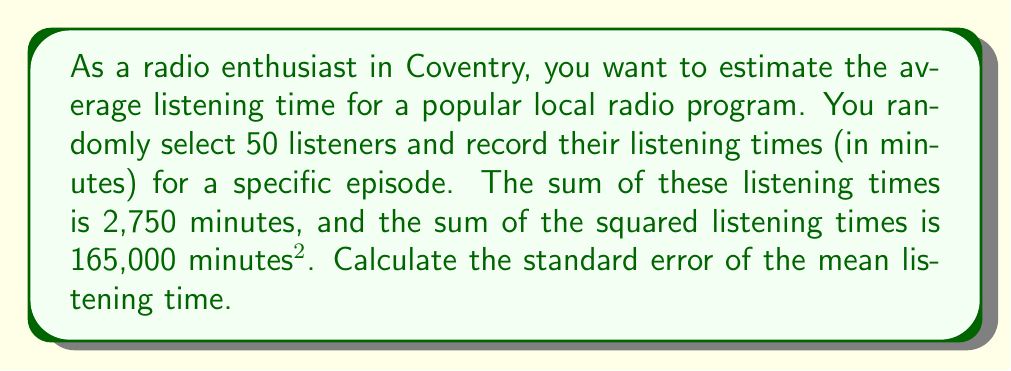Provide a solution to this math problem. To calculate the standard error of the mean, we'll follow these steps:

1) First, we need to calculate the sample mean ($\bar{x}$):
   $$\bar{x} = \frac{\sum x}{n} = \frac{2750}{50} = 55$$ minutes

2) Next, we need to calculate the sample variance ($s^2$):
   $$s^2 = \frac{\sum x^2 - n\bar{x}^2}{n-1}$$

   Where $\sum x^2 = 165000$ and $n\bar{x}^2 = 50 \times 55^2 = 151250$

   $$s^2 = \frac{165000 - 151250}{49} = \frac{13750}{49} = 280.61$$

3) Now we can calculate the sample standard deviation ($s$):
   $$s = \sqrt{280.61} = 16.75$$ minutes

4) Finally, we can calculate the standard error of the mean ($SE_{\bar{x}}$):
   $$SE_{\bar{x}} = \frac{s}{\sqrt{n}} = \frac{16.75}{\sqrt{50}} = \frac{16.75}{7.07} = 2.37$$ minutes
Answer: $2.37$ minutes 